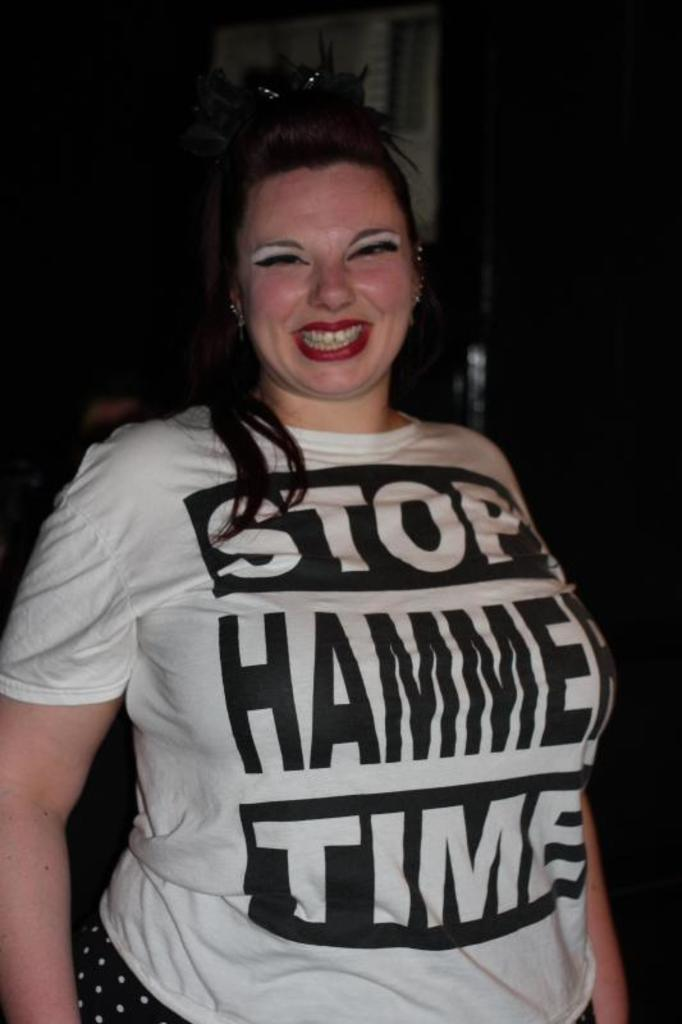<image>
Create a compact narrative representing the image presented. A woman smiling wearing a shirt that says "stop hammer time." 